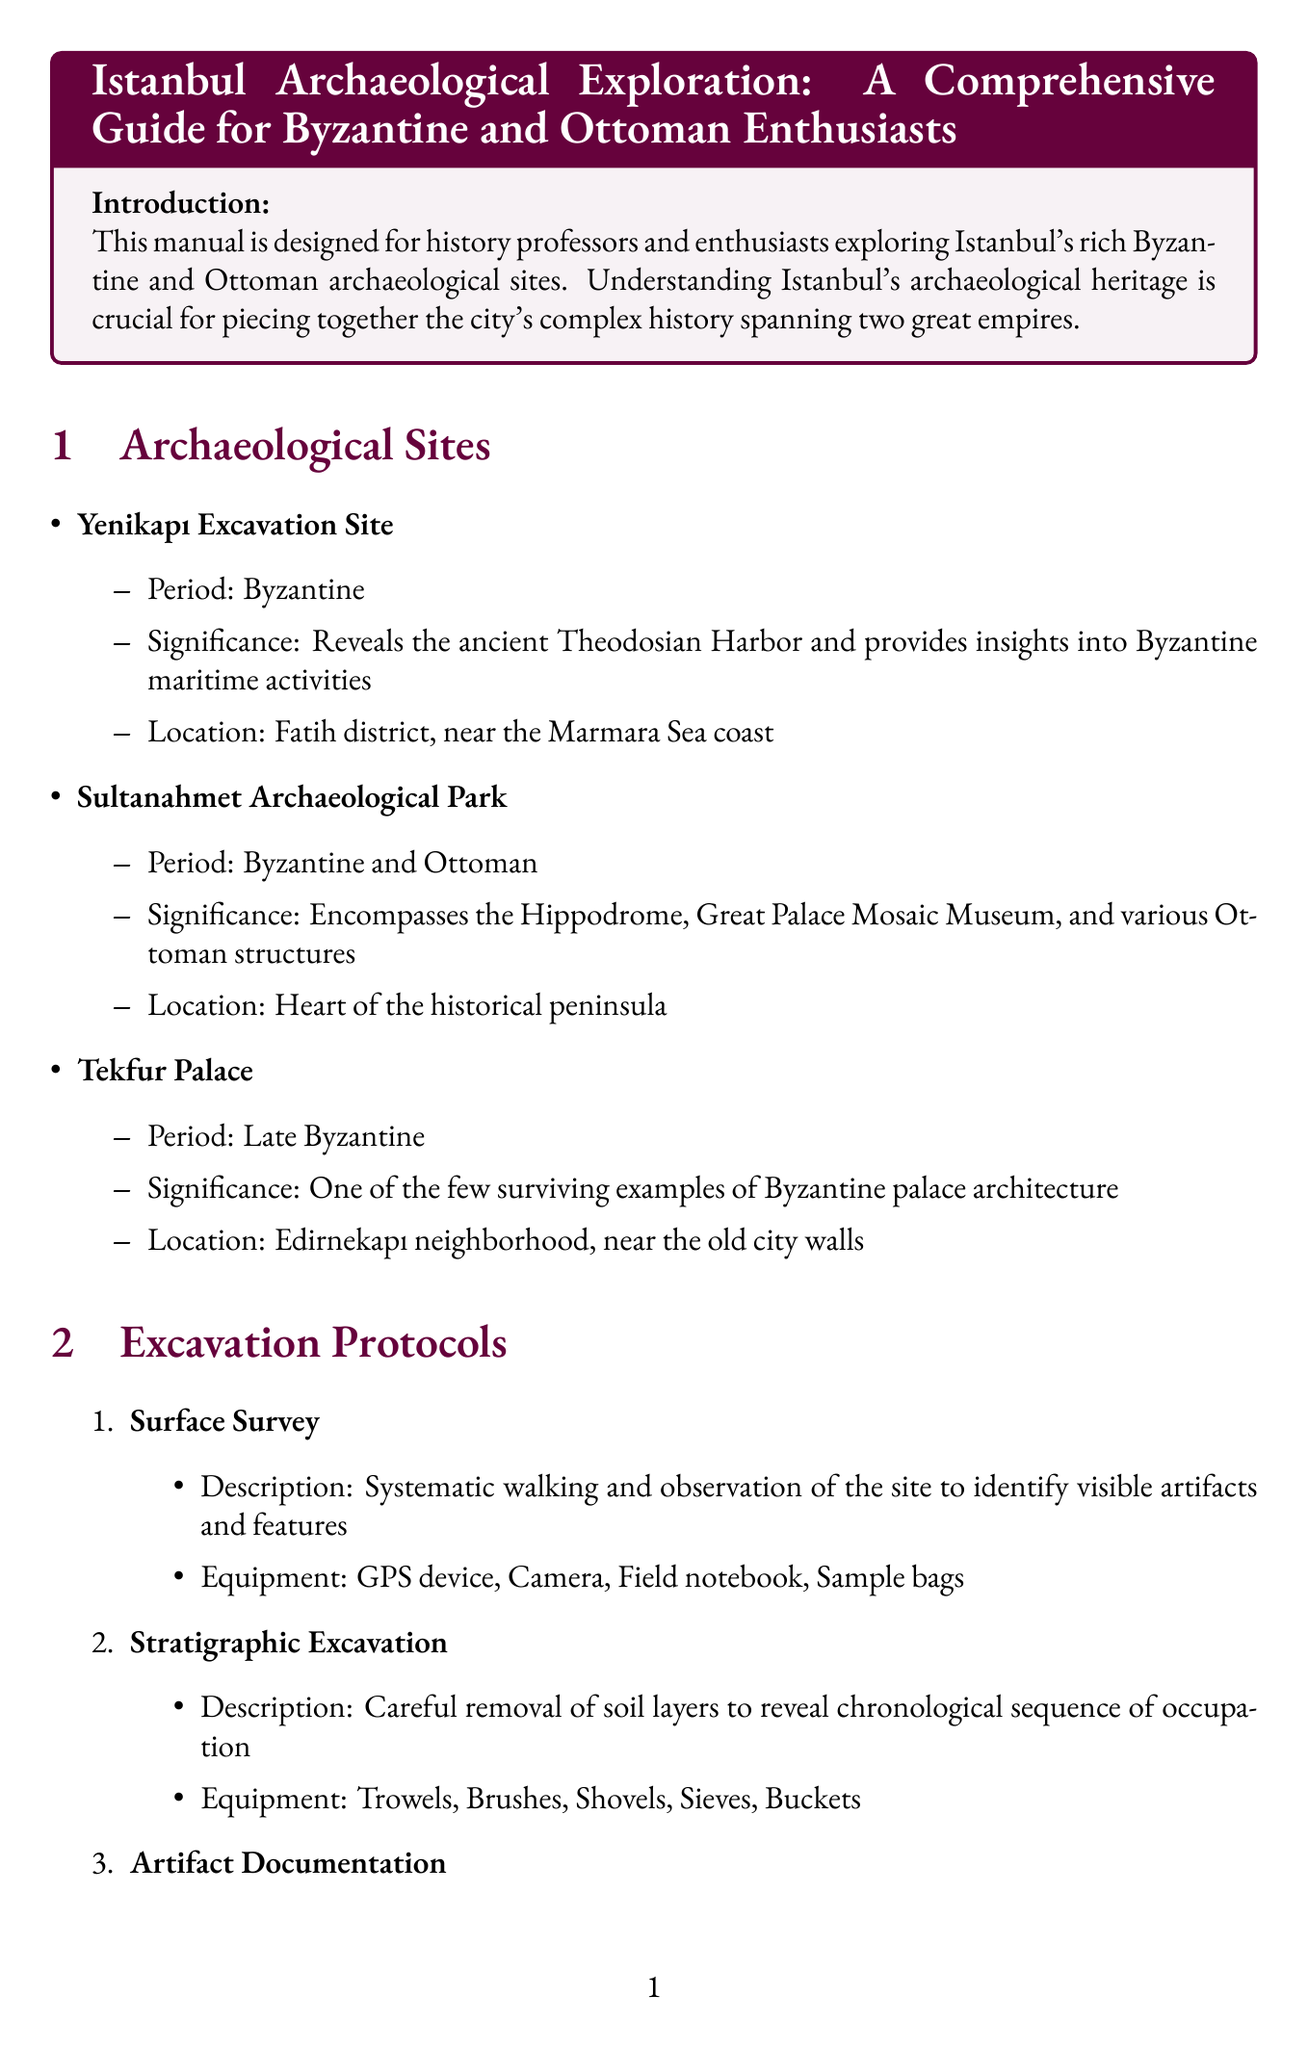what is the title of the manual? The title is the main heading at the beginning of the document, which serves as the title of the guide.
Answer: Istanbul Archaeological Exploration: A Comprehensive Guide for Byzantine and Ottoman Enthusiasts where is the Yenikapı Excavation Site located? The location is explicitly mentioned in the list of archaeological sites, associating the site with a specific district.
Answer: Fatih district, near the Marmara Sea coast what equipment is used for Stratigraphic Excavation? The equipment is listed as essential tools in the excavation protocols section for this specific method of excavation.
Answer: Trowels, Brushes, Shovels, Sieves, Buckets which category includes Glazed White Ware? The category is clearly defined in the artifact identification guides, indicating the types of artifacts that belong to this specific group.
Answer: Byzantine Ceramics what are the key landmarks shown in the Historical Peninsula Archaeological Map? Key landmarks are specified in the maps and plans section, highlighting significant historical sites within the old city walls.
Answer: Hagia Sophia, Topkapı Palace, Theodosian Walls what specialized resource is located in Beyoğlu? The specific resource is mentioned in the research resources section, indicating its location and specialization.
Answer: American Research Institute in Turkey which excavation protocol involves systematic walking? The method is detailed in the excavation protocols section, explaining its purpose and approach.
Answer: Surface Survey what are the three key areas on the Ottoman Istanbul Development Plan? The key areas are mentioned in the map description, summarizing the significant locations of the city's expansion.
Answer: Fatih district, Golden Horn shoreline, Galata neighborhood 